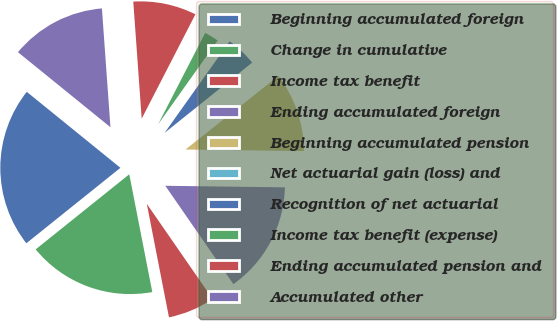Convert chart. <chart><loc_0><loc_0><loc_500><loc_500><pie_chart><fcel>Beginning accumulated foreign<fcel>Change in cumulative<fcel>Income tax benefit<fcel>Ending accumulated foreign<fcel>Beginning accumulated pension<fcel>Net actuarial gain (loss) and<fcel>Recognition of net actuarial<fcel>Income tax benefit (expense)<fcel>Ending accumulated pension and<fcel>Accumulated other<nl><fcel>21.61%<fcel>17.31%<fcel>6.56%<fcel>15.16%<fcel>10.86%<fcel>0.11%<fcel>4.41%<fcel>2.26%<fcel>8.71%<fcel>13.01%<nl></chart> 